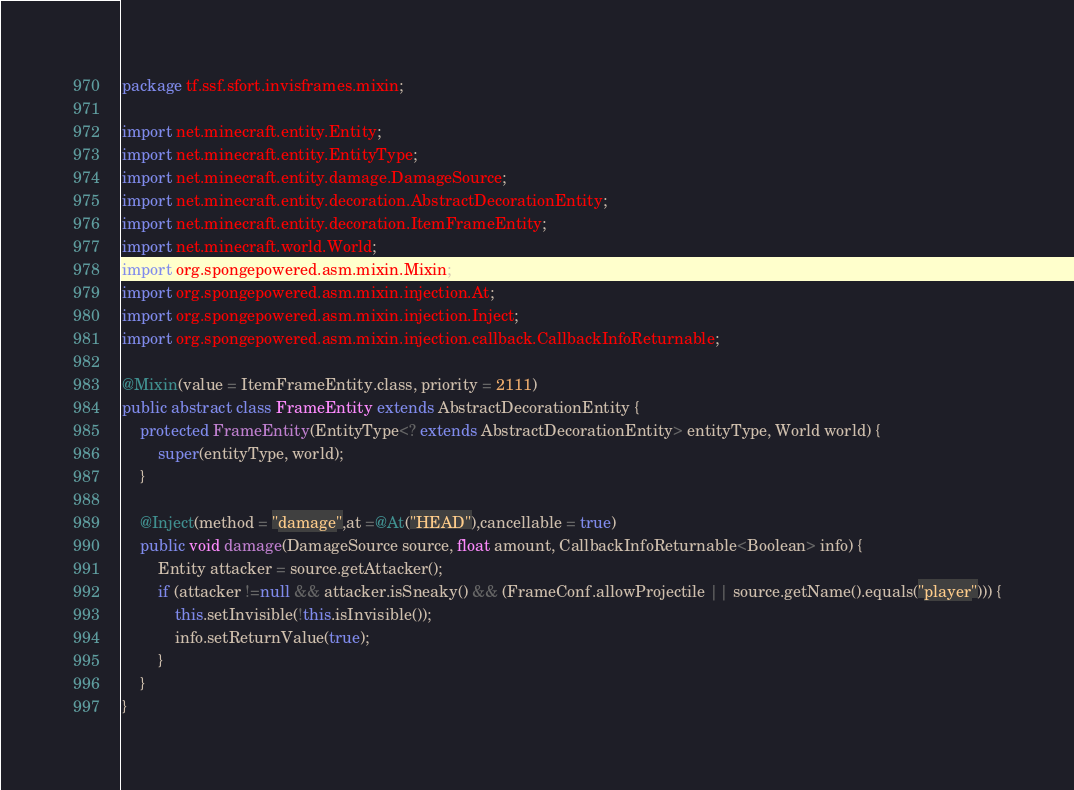Convert code to text. <code><loc_0><loc_0><loc_500><loc_500><_Java_>package tf.ssf.sfort.invisframes.mixin;

import net.minecraft.entity.Entity;
import net.minecraft.entity.EntityType;
import net.minecraft.entity.damage.DamageSource;
import net.minecraft.entity.decoration.AbstractDecorationEntity;
import net.minecraft.entity.decoration.ItemFrameEntity;
import net.minecraft.world.World;
import org.spongepowered.asm.mixin.Mixin;
import org.spongepowered.asm.mixin.injection.At;
import org.spongepowered.asm.mixin.injection.Inject;
import org.spongepowered.asm.mixin.injection.callback.CallbackInfoReturnable;

@Mixin(value = ItemFrameEntity.class, priority = 2111)
public abstract class FrameEntity extends AbstractDecorationEntity {
	protected FrameEntity(EntityType<? extends AbstractDecorationEntity> entityType, World world) {
		super(entityType, world);
	}

	@Inject(method = "damage",at =@At("HEAD"),cancellable = true)
	public void damage(DamageSource source, float amount, CallbackInfoReturnable<Boolean> info) {
		Entity attacker = source.getAttacker();
		if (attacker !=null && attacker.isSneaky() && (FrameConf.allowProjectile || source.getName().equals("player"))) {
			this.setInvisible(!this.isInvisible());
			info.setReturnValue(true);
		}
	}
}
</code> 